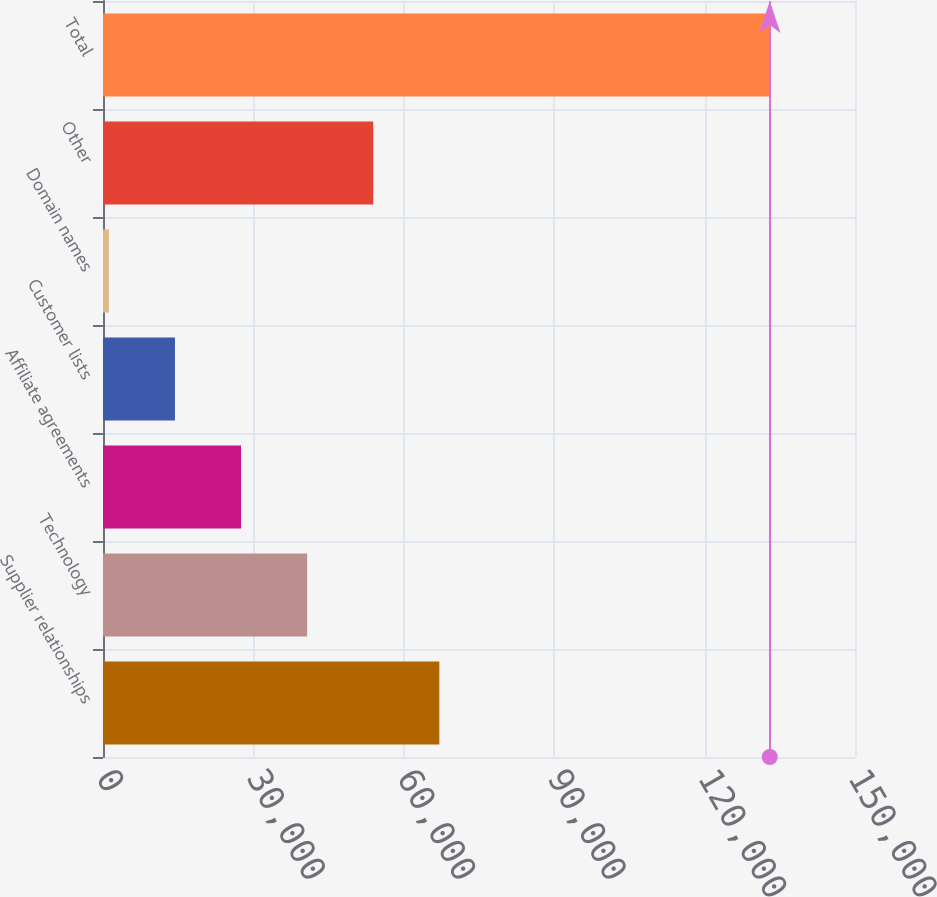<chart> <loc_0><loc_0><loc_500><loc_500><bar_chart><fcel>Supplier relationships<fcel>Technology<fcel>Affiliate agreements<fcel>Customer lists<fcel>Domain names<fcel>Other<fcel>Total<nl><fcel>67087<fcel>40720.6<fcel>27537.4<fcel>14354.2<fcel>1171<fcel>53903.8<fcel>133003<nl></chart> 